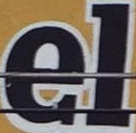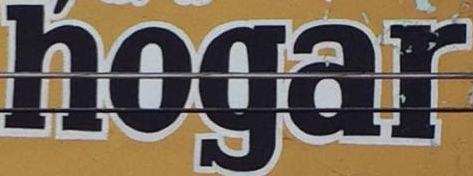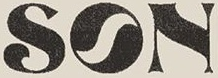What text appears in these images from left to right, separated by a semicolon? el; hogar; SON 